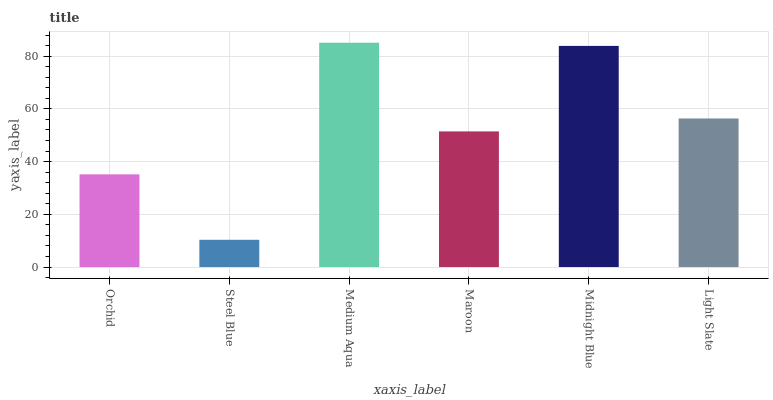Is Steel Blue the minimum?
Answer yes or no. Yes. Is Medium Aqua the maximum?
Answer yes or no. Yes. Is Medium Aqua the minimum?
Answer yes or no. No. Is Steel Blue the maximum?
Answer yes or no. No. Is Medium Aqua greater than Steel Blue?
Answer yes or no. Yes. Is Steel Blue less than Medium Aqua?
Answer yes or no. Yes. Is Steel Blue greater than Medium Aqua?
Answer yes or no. No. Is Medium Aqua less than Steel Blue?
Answer yes or no. No. Is Light Slate the high median?
Answer yes or no. Yes. Is Maroon the low median?
Answer yes or no. Yes. Is Orchid the high median?
Answer yes or no. No. Is Orchid the low median?
Answer yes or no. No. 